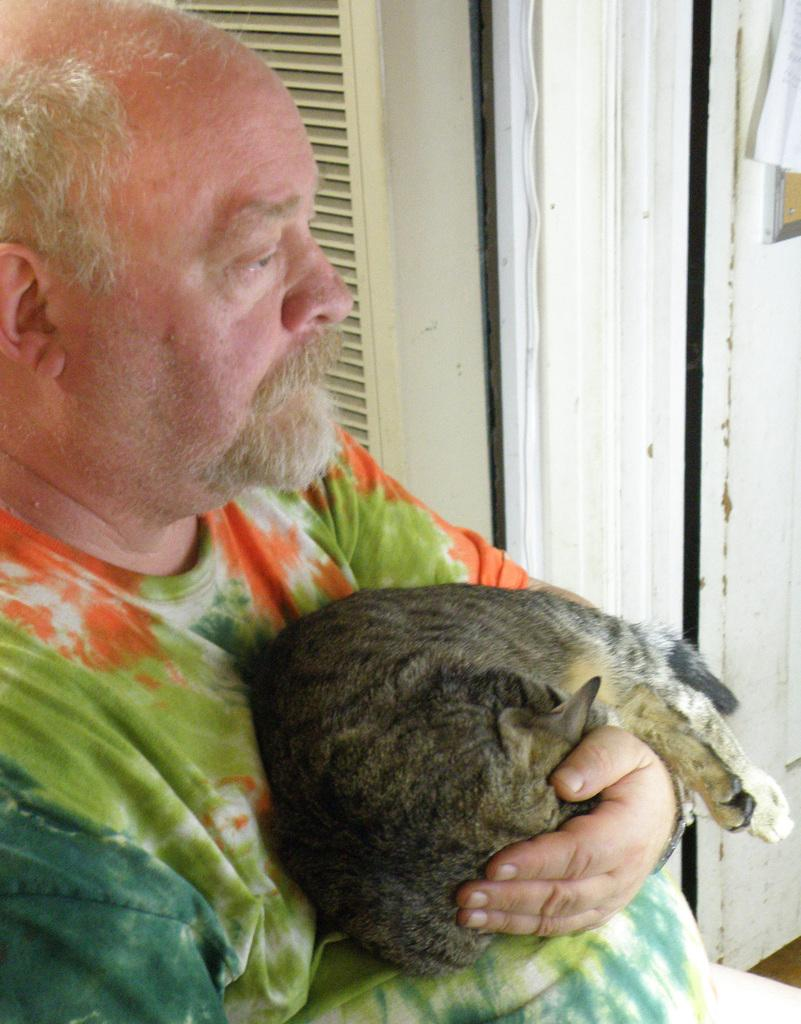Who is the main subject in the image? There is an old man in the image. What is the old man holding? The old man is holding a cat. What is the old man wearing? The old man is wearing a t-shirt. How is the t-shirt described? The t-shirt is described as "cool." What is the old man doing in the image? The old man is staring at something. What can be seen in the background of the image? There is a door in the background of the image. What type of heat or flame can be seen coming from the cat in the image? There is no heat or flame coming from the cat in the image. The cat is simply being held by the old man. 